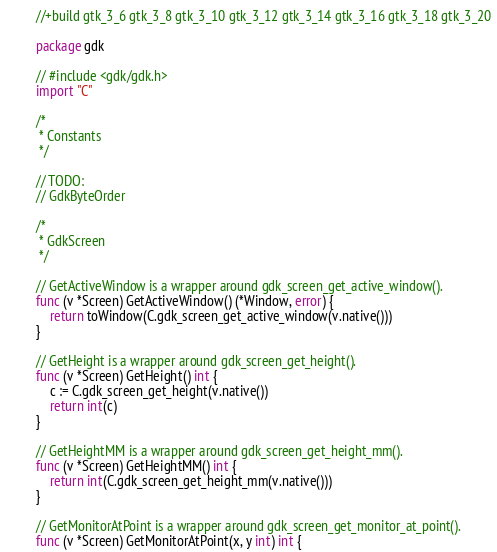Convert code to text. <code><loc_0><loc_0><loc_500><loc_500><_Go_>//+build gtk_3_6 gtk_3_8 gtk_3_10 gtk_3_12 gtk_3_14 gtk_3_16 gtk_3_18 gtk_3_20

package gdk

// #include <gdk/gdk.h>
import "C"

/*
 * Constants
 */

// TODO:
// GdkByteOrder

/*
 * GdkScreen
 */

// GetActiveWindow is a wrapper around gdk_screen_get_active_window().
func (v *Screen) GetActiveWindow() (*Window, error) {
	return toWindow(C.gdk_screen_get_active_window(v.native()))
}

// GetHeight is a wrapper around gdk_screen_get_height().
func (v *Screen) GetHeight() int {
	c := C.gdk_screen_get_height(v.native())
	return int(c)
}

// GetHeightMM is a wrapper around gdk_screen_get_height_mm().
func (v *Screen) GetHeightMM() int {
	return int(C.gdk_screen_get_height_mm(v.native()))
}

// GetMonitorAtPoint is a wrapper around gdk_screen_get_monitor_at_point().
func (v *Screen) GetMonitorAtPoint(x, y int) int {</code> 